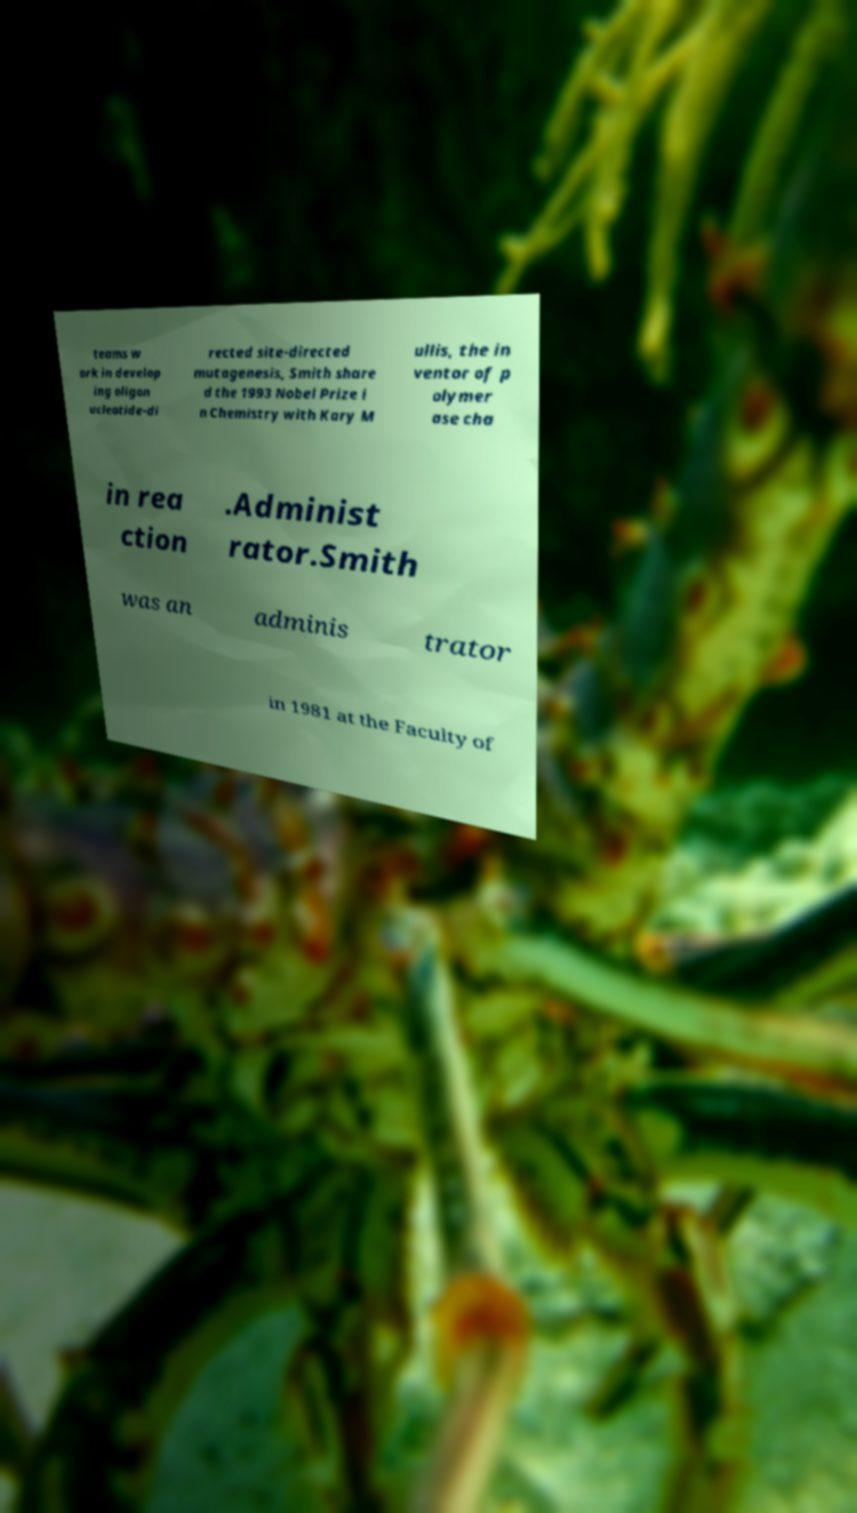Can you accurately transcribe the text from the provided image for me? teams w ork in develop ing oligon ucleotide-di rected site-directed mutagenesis, Smith share d the 1993 Nobel Prize i n Chemistry with Kary M ullis, the in ventor of p olymer ase cha in rea ction .Administ rator.Smith was an adminis trator in 1981 at the Faculty of 